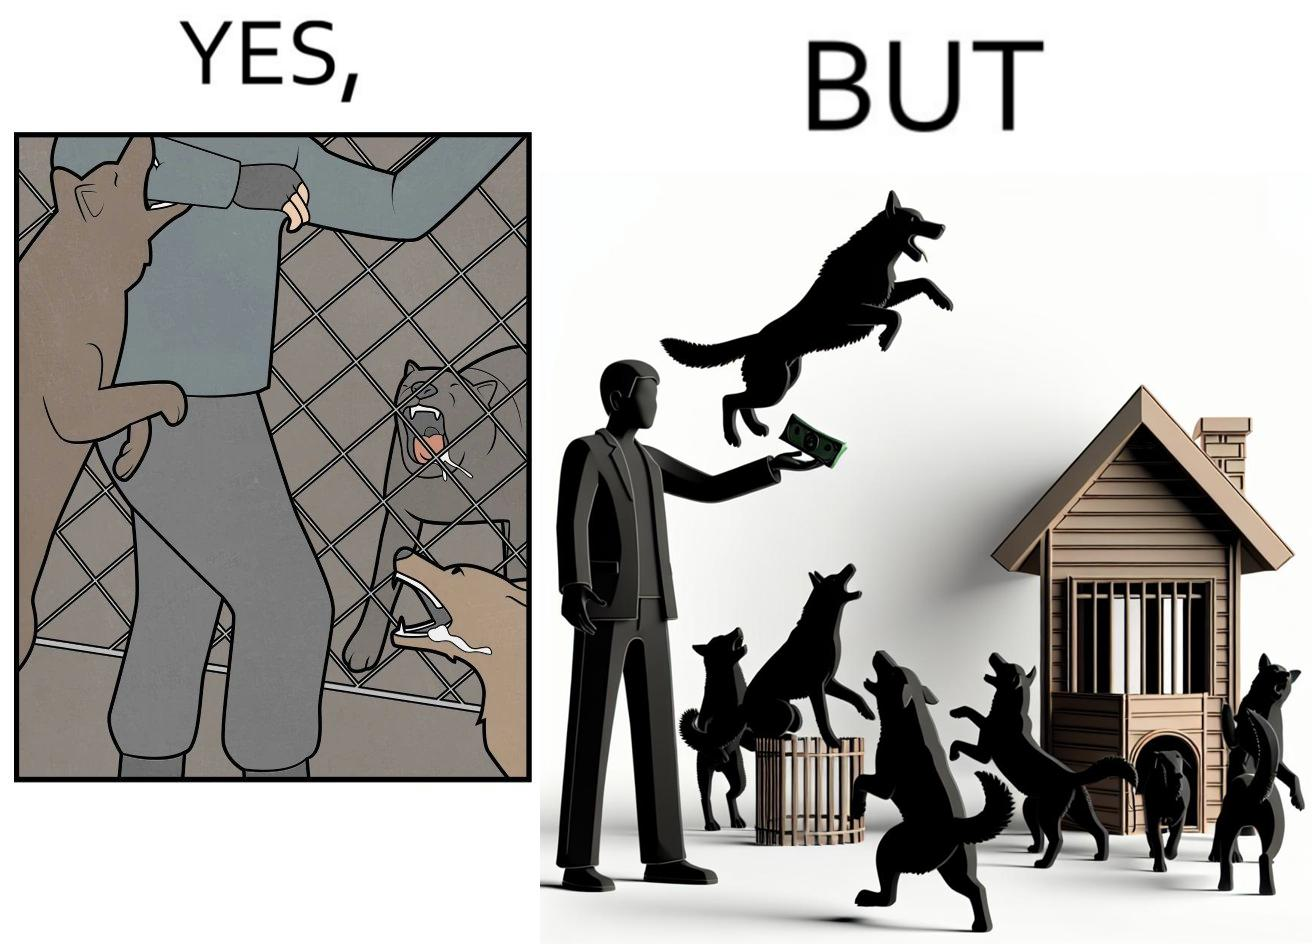Describe the content of this image. The images are ironic since they show how dogs choose to attack a well wisher making a donation for helping dogs. It is sad that dogs mistake a well wisher and bite him while he is trying to help them. 